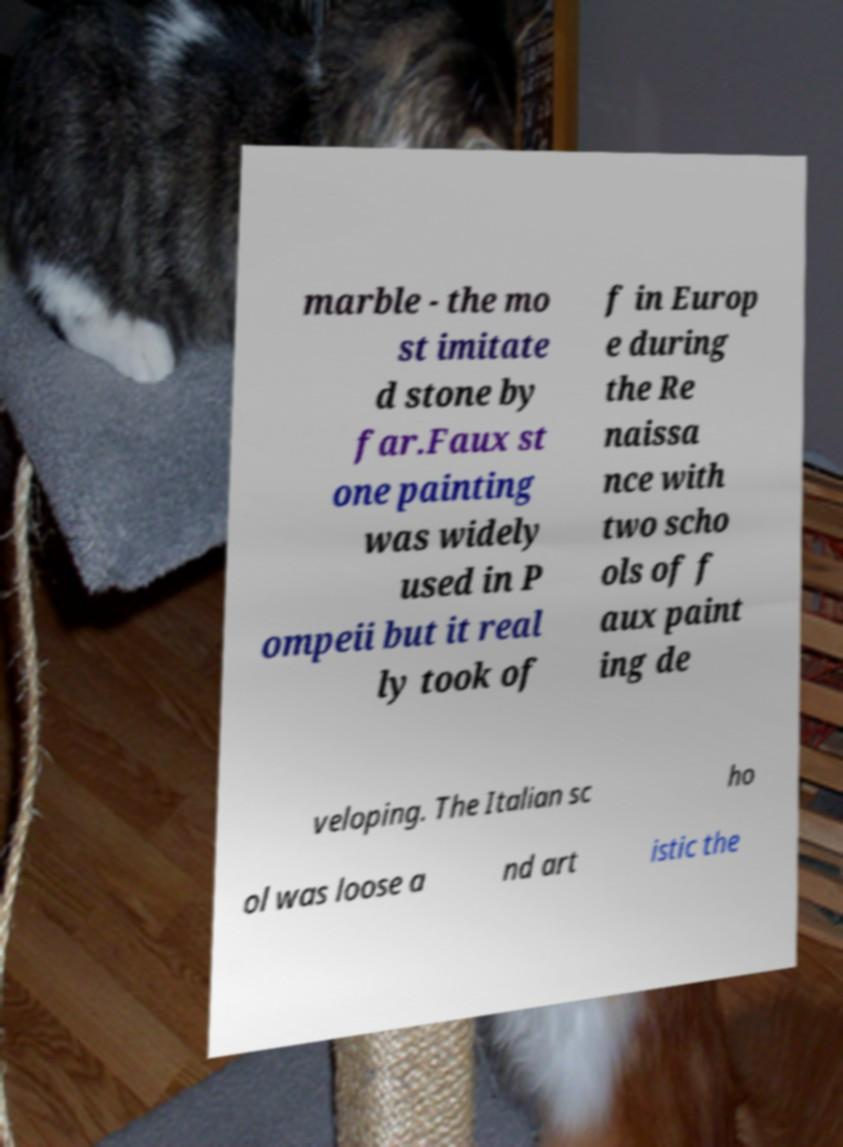Please identify and transcribe the text found in this image. marble - the mo st imitate d stone by far.Faux st one painting was widely used in P ompeii but it real ly took of f in Europ e during the Re naissa nce with two scho ols of f aux paint ing de veloping. The Italian sc ho ol was loose a nd art istic the 